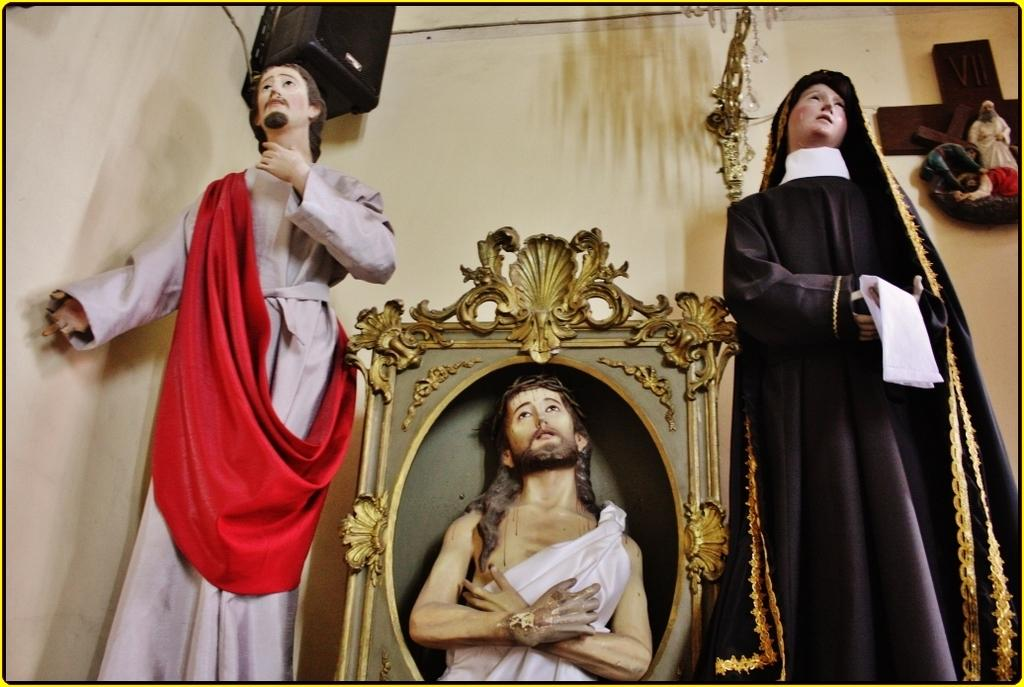How many person statues are in the image? There are four person statues in the image. What other object can be seen in the image? There is a speaker in the image. What is the background of the image? There is a wall in the image. What type of image is this? The image appears to be a photo frame. Can you see any cows in the image? No, there are no cows present in the image. What type of observation can be made about the person statues in the image? The question is unclear and cannot be answered definitively based on the provided facts. 